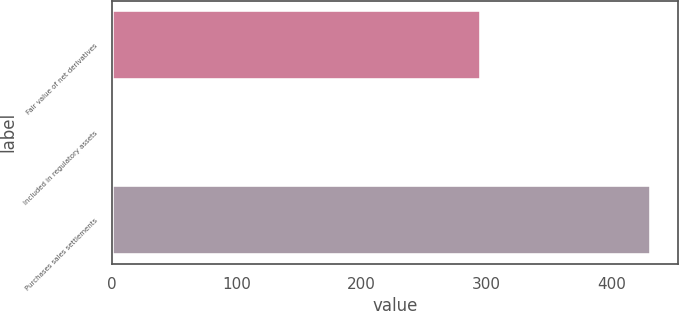Convert chart to OTSL. <chart><loc_0><loc_0><loc_500><loc_500><bar_chart><fcel>Fair value of net derivatives<fcel>Included in regulatory assets<fcel>Purchases sales settlements<nl><fcel>296<fcel>1<fcel>432<nl></chart> 